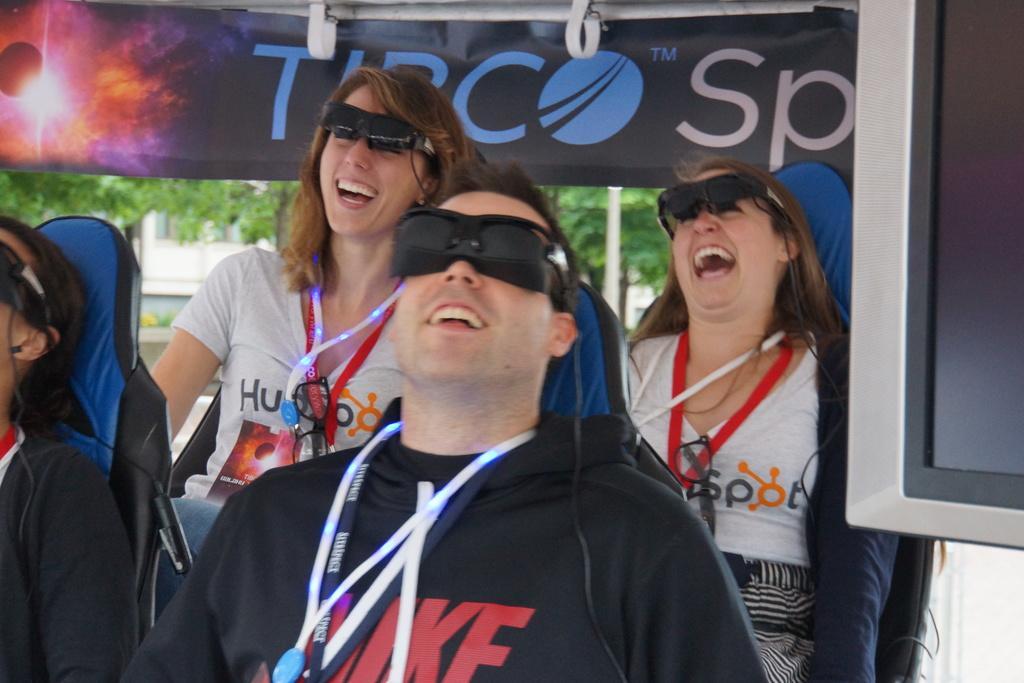In one or two sentences, can you explain what this image depicts? In the center of the image we can see a few people are sitting on the chairs. And they are smiling, which we can see on their faces. And they are wearing glasses. On the right side of the image, there is a monitor. In the background we can see trees, one building, pole, one banner etc. 